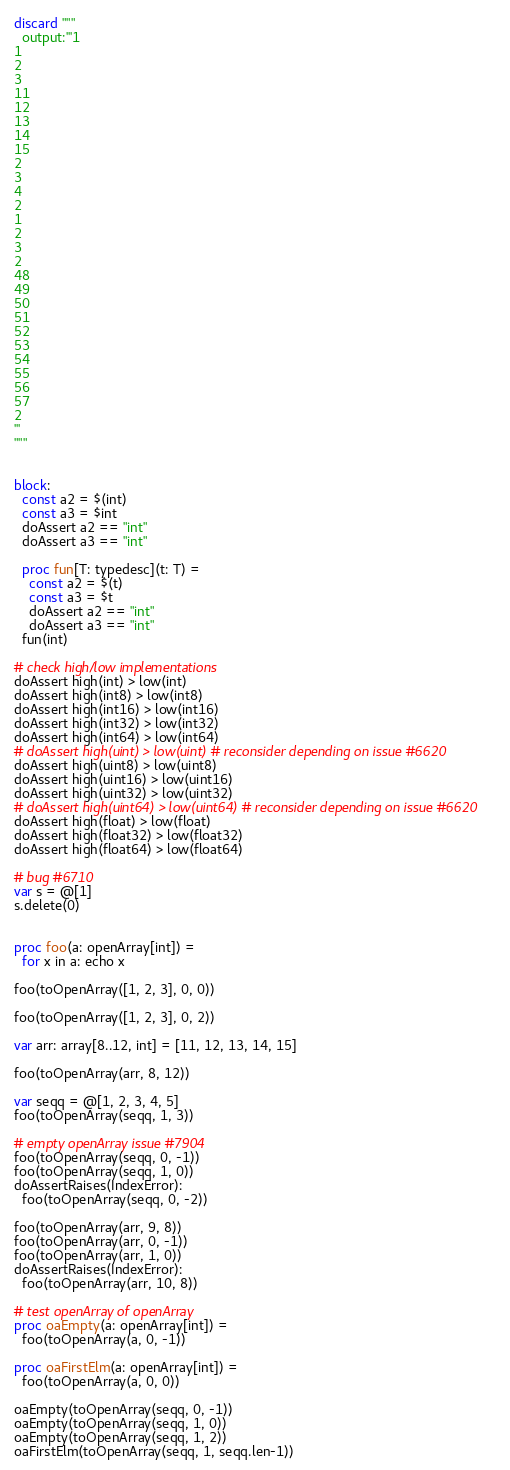Convert code to text. <code><loc_0><loc_0><loc_500><loc_500><_Nim_>discard """
  output:'''1
1
2
3
11
12
13
14
15
2
3
4
2
1
2
3
2
48
49
50
51
52
53
54
55
56
57
2
'''
"""


block:
  const a2 = $(int)
  const a3 = $int
  doAssert a2 == "int"
  doAssert a3 == "int"

  proc fun[T: typedesc](t: T) =
    const a2 = $(t)
    const a3 = $t
    doAssert a2 == "int"
    doAssert a3 == "int"
  fun(int)

# check high/low implementations
doAssert high(int) > low(int)
doAssert high(int8) > low(int8)
doAssert high(int16) > low(int16)
doAssert high(int32) > low(int32)
doAssert high(int64) > low(int64)
# doAssert high(uint) > low(uint) # reconsider depending on issue #6620
doAssert high(uint8) > low(uint8)
doAssert high(uint16) > low(uint16)
doAssert high(uint32) > low(uint32)
# doAssert high(uint64) > low(uint64) # reconsider depending on issue #6620
doAssert high(float) > low(float)
doAssert high(float32) > low(float32)
doAssert high(float64) > low(float64)

# bug #6710
var s = @[1]
s.delete(0)


proc foo(a: openArray[int]) =
  for x in a: echo x

foo(toOpenArray([1, 2, 3], 0, 0))

foo(toOpenArray([1, 2, 3], 0, 2))

var arr: array[8..12, int] = [11, 12, 13, 14, 15]

foo(toOpenArray(arr, 8, 12))

var seqq = @[1, 2, 3, 4, 5]
foo(toOpenArray(seqq, 1, 3))

# empty openArray issue #7904
foo(toOpenArray(seqq, 0, -1))
foo(toOpenArray(seqq, 1, 0))
doAssertRaises(IndexError):
  foo(toOpenArray(seqq, 0, -2))

foo(toOpenArray(arr, 9, 8))
foo(toOpenArray(arr, 0, -1))
foo(toOpenArray(arr, 1, 0))
doAssertRaises(IndexError):
  foo(toOpenArray(arr, 10, 8))

# test openArray of openArray
proc oaEmpty(a: openArray[int]) =
  foo(toOpenArray(a, 0, -1))

proc oaFirstElm(a: openArray[int]) =
  foo(toOpenArray(a, 0, 0))

oaEmpty(toOpenArray(seqq, 0, -1))
oaEmpty(toOpenArray(seqq, 1, 0))
oaEmpty(toOpenArray(seqq, 1, 2))
oaFirstElm(toOpenArray(seqq, 1, seqq.len-1))
</code> 